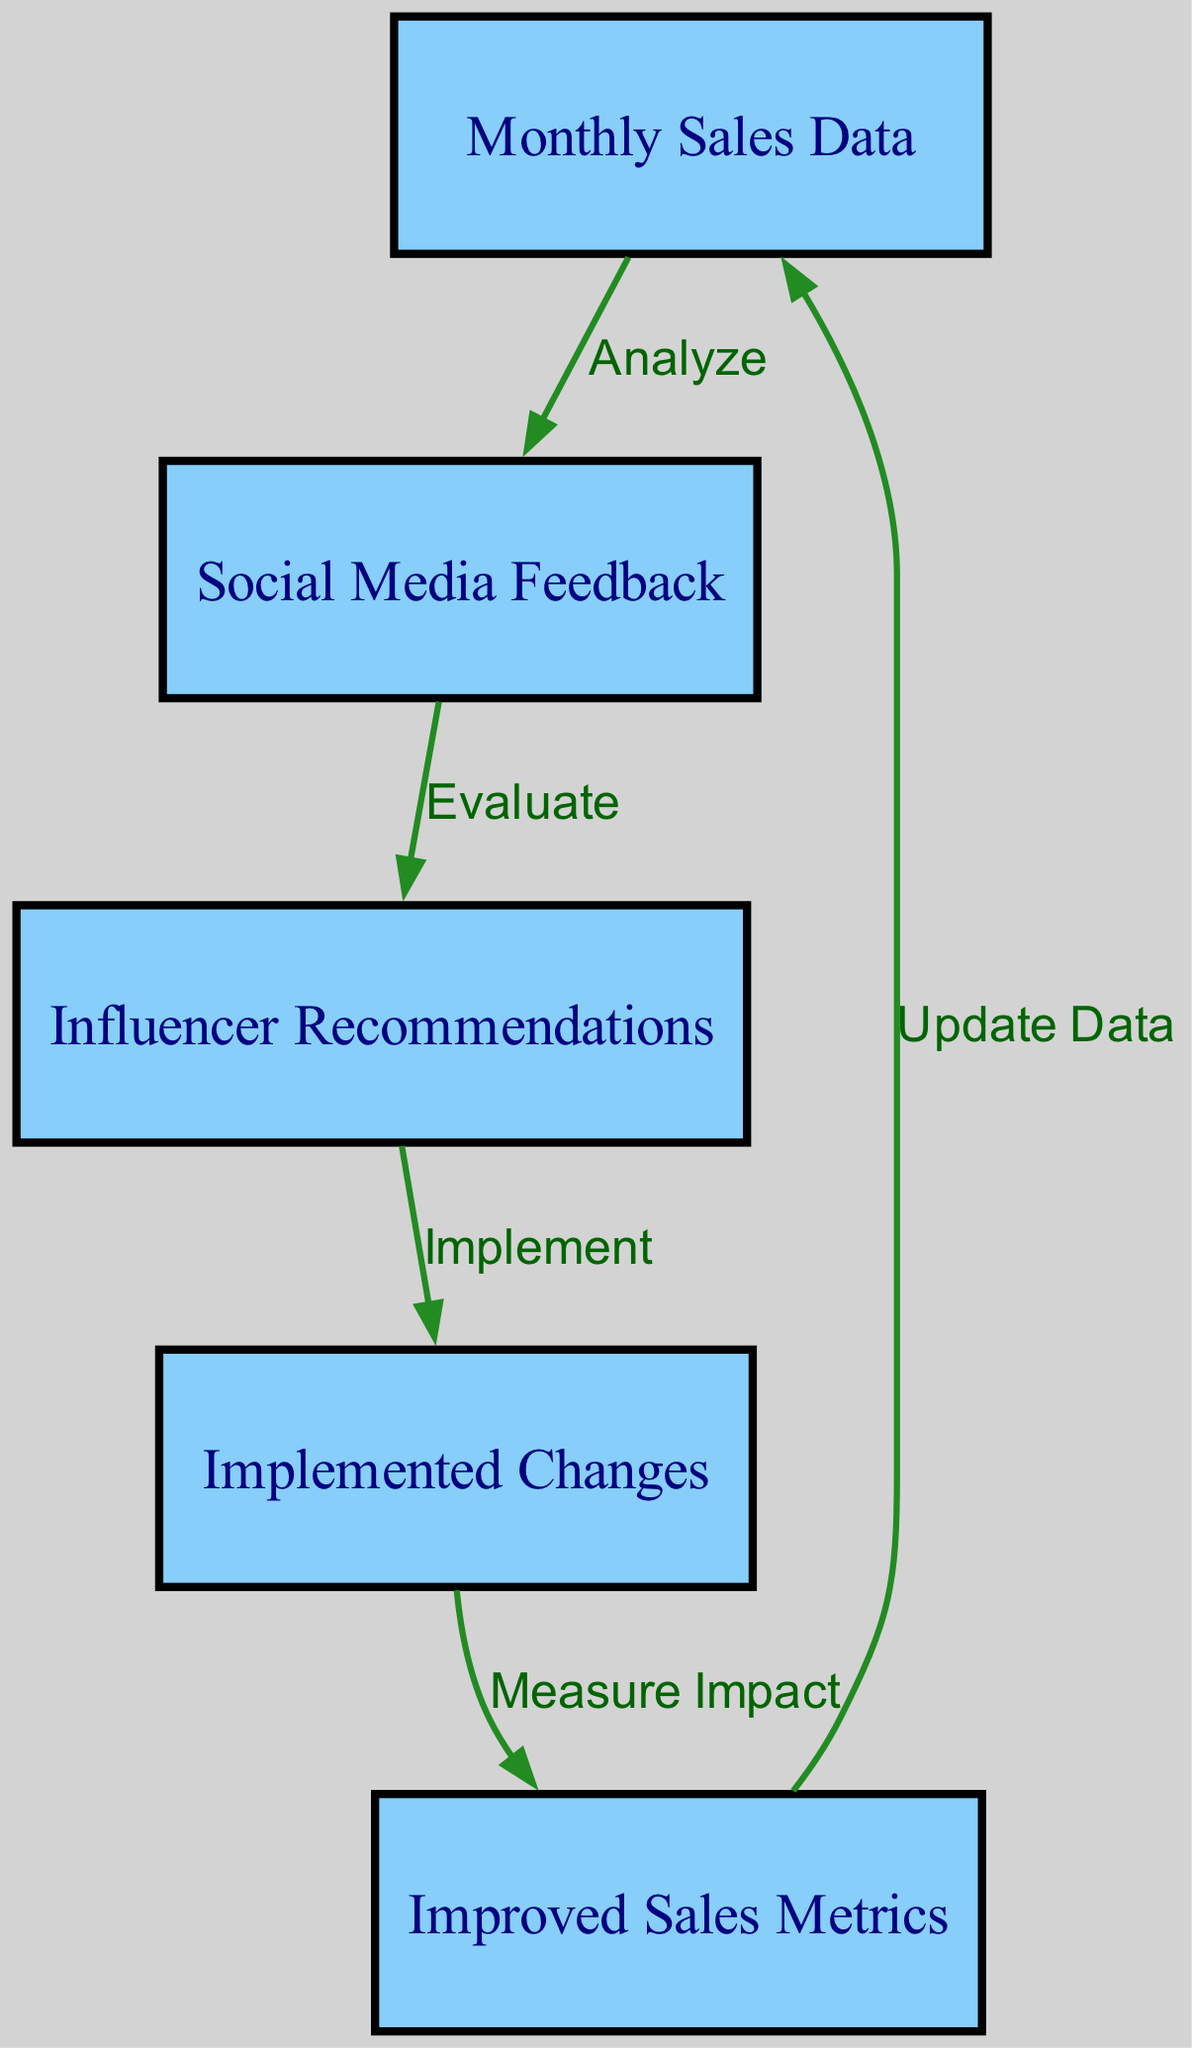What is the first step indicated in the diagram? The diagram begins with the node labeled "Monthly Sales Data," which shows that the analysis starts with sales data.
Answer: Monthly Sales Data How many nodes are present in the diagram? The diagram features five nodes: Monthly Sales Data, Social Media Feedback, Influencer Recommendations, Implemented Changes, and Improved Sales Metrics.
Answer: Five What is the label of the edge leading from "Social Media Feedback" to "Influencer Recommendations"? The edge between these two nodes is labeled "Evaluate," indicating the action taken based on social media feedback.
Answer: Evaluate Which node shows the final outcome of the influencer's suggestions? The node labeled "Improved Sales Metrics" reflects the results following the implementation of recommended changes.
Answer: Improved Sales Metrics What action is taken based on "Influencer Recommendations"? The edge connecting "Influencer Recommendations" to "Implemented Changes" is labeled "Implement," indicating that changes are made based on influencer suggestions.
Answer: Implement What is the relationship between "Improved Sales Metrics" and "Monthly Sales Data"? The edge leading back to "Monthly Sales Data" from "Improved Sales Metrics" is labeled "Update Data," suggesting that improved metrics will help update future sales data.
Answer: Update Data Which nodes have an outgoing edge? The nodes "Monthly Sales Data," "Social Media Feedback," "Influencer Recommendations," and "Implemented Changes" all have outgoing edges, indicating they lead to further actions or outcomes in the flow.
Answer: Four nodes What feedback source is analyzed for potential improvements? The node labeled "Social Media Feedback" is utilized for analysis to assess potential changes based on influencer feedback.
Answer: Social Media Feedback 